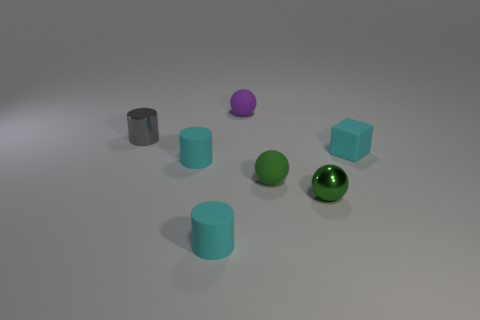There is a matte object behind the gray metal cylinder that is on the left side of the shiny sphere; what is its color?
Give a very brief answer. Purple. What color is the shiny cylinder that is the same size as the green shiny object?
Make the answer very short. Gray. Are there any tiny things of the same color as the tiny cube?
Your answer should be very brief. Yes. Are any shiny cylinders visible?
Ensure brevity in your answer.  Yes. The small green thing that is behind the tiny green metal thing has what shape?
Your answer should be very brief. Sphere. How many things are both to the right of the tiny gray thing and behind the small green matte ball?
Ensure brevity in your answer.  3. What number of other objects are there of the same size as the rubber cube?
Keep it short and to the point. 6. Does the small thing that is behind the shiny cylinder have the same shape as the tiny metal thing that is in front of the small rubber block?
Ensure brevity in your answer.  Yes. How many objects are either metal spheres or tiny rubber things that are in front of the tiny gray thing?
Your answer should be very brief. 5. There is a small cyan thing that is both in front of the cyan block and behind the tiny green matte ball; what is its material?
Keep it short and to the point. Rubber. 